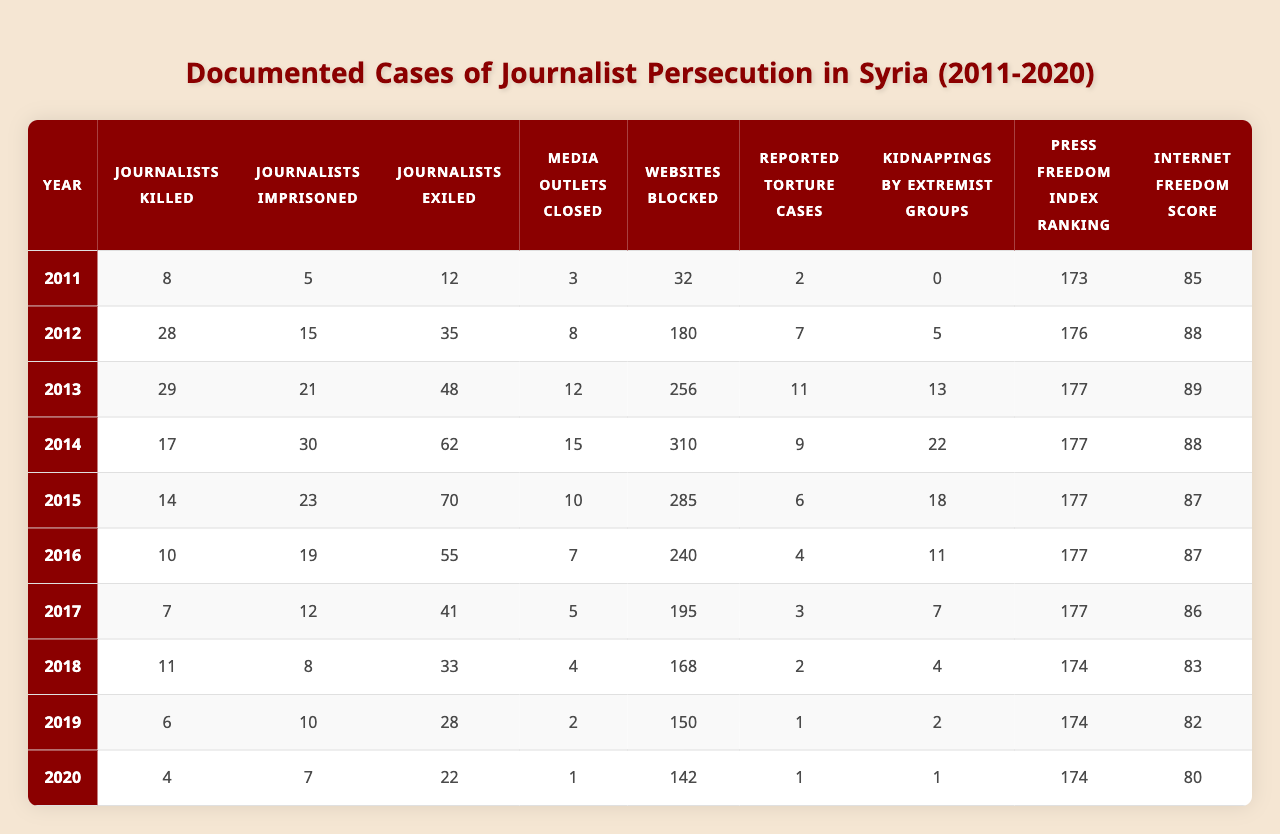What year saw the highest number of journalists imprisoned in Syria? The data shows the number of journalists imprisoned for each year. The highest value is 30 in the year 2014.
Answer: 2014 How many journalists were killed in 2012? According to the table, the number of journalists killed in 2012 is 28.
Answer: 28 What is the total number of journalists exiled from 2011 to 2020? To find the total, add the number of exiled journalists each year: 12 + 35 + 48 + 62 + 70 + 55 + 41 + 33 + 28 + 22 =  435.
Answer: 435 Which year had the lowest number of journalists killed? The table indicates that the year with the lowest number of journalists killed is 2020, with 4 killed.
Answer: 2020 Did the number of media outlets closed decrease from 2015 to 2020? In 2015, 10 media outlets were closed, while in 2020, only 1 was closed. This indicates a decrease.
Answer: Yes What is the average number of journalists killed per year from 2011 to 2020? The sum of journalists killed from 2011 to 2020 is 8 + 28 + 29 + 17 + 14 + 10 + 7 + 11 + 6 + 4 =  8 + 28 + 29 + 17 + 14 + 10 + 7 + 11 + 6 + 4 =  8 + 28 + 29 + 17 + 14 + 10 + 7 + 11 + 6 + 4 =  8 + 28 + 29 + 17 + 14 + 10 + 7 + 11 + 8 + 6 + 4 = 8 + 28 + 29 + 17 + 14 + 10 + 7 + 11 + 8 + 6 + 4 = 169. Dividing by 10 (the number of years), the average is 169 / 10 = 16.9.
Answer: 16.9 What is the trend in the number of kidnappings by extremist groups from 2011 to 2020? The data shows that kidnappings by extremist groups increased from 0 in 2011 to a peak of 22 in 2014 and then gradually decreased to 1 in 2020, indicating a decline after 2014.
Answer: Increased then decreased Which year had the highest Press Freedom Index ranking? The Press Freedom Index ranking is highest (least negative) in 2018 and 2019, with a ranking of 174.
Answer: 2018, 2019 How many websites were blocked in Syria in 2016 compared to 2020? In 2016, 240 websites were blocked, while in 2020, 142 were blocked. Therefore, 240 - 142 = 98 less were blocked in 2020.
Answer: 98 less Was the number of reported torture cases highest in 2013? The table shows that the highest number of reported torture cases was 11 in 2013, confirming this statement as true.
Answer: Yes 